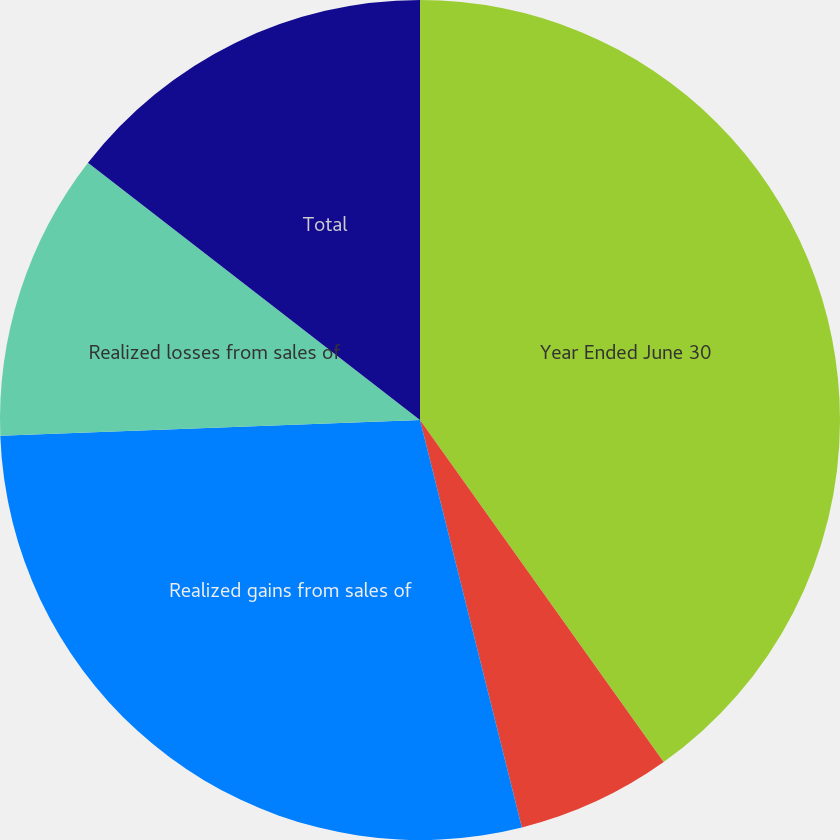Convert chart to OTSL. <chart><loc_0><loc_0><loc_500><loc_500><pie_chart><fcel>Year Ended June 30<fcel>Other-than-temporary<fcel>Realized gains from sales of<fcel>Realized losses from sales of<fcel>Total<nl><fcel>40.15%<fcel>5.95%<fcel>28.3%<fcel>11.09%<fcel>14.51%<nl></chart> 